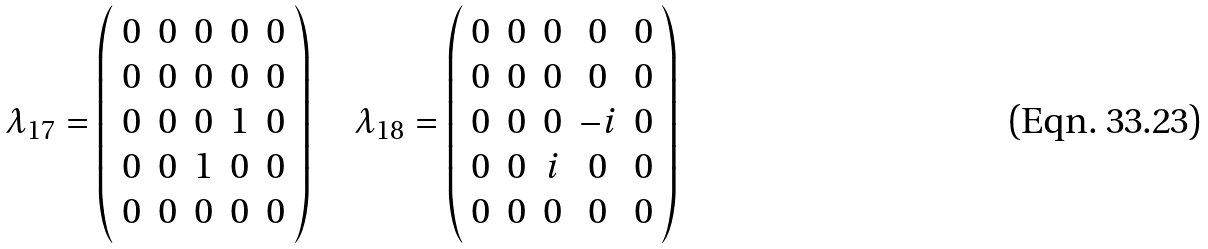<formula> <loc_0><loc_0><loc_500><loc_500>\lambda _ { 1 7 } = \left ( \begin{array} { c c c c c } 0 & 0 & 0 & 0 & 0 \\ 0 & 0 & 0 & 0 & 0 \\ 0 & 0 & 0 & 1 & 0 \\ 0 & 0 & 1 & 0 & 0 \\ 0 & 0 & 0 & 0 & 0 \end{array} \right ) \quad \lambda _ { 1 8 } = \left ( \begin{array} { c c c c c } 0 & 0 & 0 & 0 & 0 \\ 0 & 0 & 0 & 0 & 0 \\ 0 & 0 & 0 & - i & 0 \\ 0 & 0 & i & 0 & 0 \\ 0 & 0 & 0 & 0 & 0 \end{array} \right )</formula> 